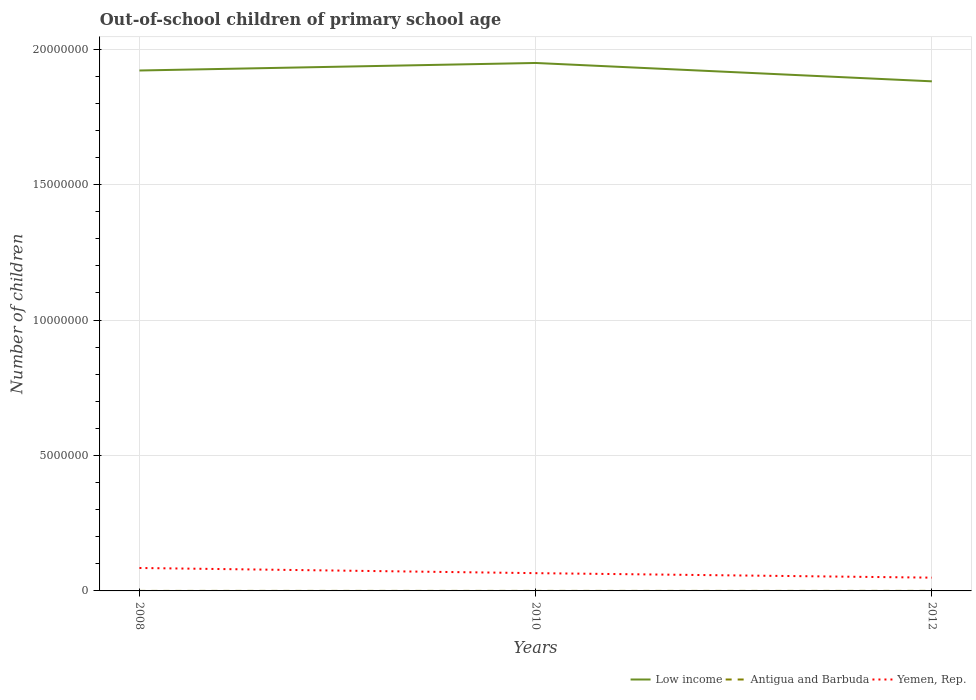How many different coloured lines are there?
Make the answer very short. 3. Does the line corresponding to Yemen, Rep. intersect with the line corresponding to Low income?
Your response must be concise. No. Is the number of lines equal to the number of legend labels?
Your answer should be compact. Yes. Across all years, what is the maximum number of out-of-school children in Yemen, Rep.?
Keep it short and to the point. 4.90e+05. In which year was the number of out-of-school children in Yemen, Rep. maximum?
Provide a short and direct response. 2012. What is the total number of out-of-school children in Yemen, Rep. in the graph?
Offer a very short reply. 1.66e+05. What is the difference between the highest and the second highest number of out-of-school children in Antigua and Barbuda?
Keep it short and to the point. 712. Is the number of out-of-school children in Yemen, Rep. strictly greater than the number of out-of-school children in Low income over the years?
Your answer should be compact. Yes. What is the difference between two consecutive major ticks on the Y-axis?
Keep it short and to the point. 5.00e+06. Does the graph contain any zero values?
Ensure brevity in your answer.  No. Does the graph contain grids?
Your answer should be compact. Yes. Where does the legend appear in the graph?
Offer a terse response. Bottom right. How are the legend labels stacked?
Provide a short and direct response. Horizontal. What is the title of the graph?
Your answer should be compact. Out-of-school children of primary school age. Does "Middle East & North Africa (developing only)" appear as one of the legend labels in the graph?
Provide a succinct answer. No. What is the label or title of the X-axis?
Your answer should be compact. Years. What is the label or title of the Y-axis?
Provide a succinct answer. Number of children. What is the Number of children of Low income in 2008?
Give a very brief answer. 1.92e+07. What is the Number of children in Antigua and Barbuda in 2008?
Offer a terse response. 786. What is the Number of children of Yemen, Rep. in 2008?
Offer a very short reply. 8.47e+05. What is the Number of children in Low income in 2010?
Keep it short and to the point. 1.95e+07. What is the Number of children of Antigua and Barbuda in 2010?
Give a very brief answer. 1146. What is the Number of children in Yemen, Rep. in 2010?
Provide a short and direct response. 6.56e+05. What is the Number of children of Low income in 2012?
Offer a very short reply. 1.88e+07. What is the Number of children in Antigua and Barbuda in 2012?
Provide a short and direct response. 1498. What is the Number of children of Yemen, Rep. in 2012?
Your answer should be compact. 4.90e+05. Across all years, what is the maximum Number of children of Low income?
Make the answer very short. 1.95e+07. Across all years, what is the maximum Number of children in Antigua and Barbuda?
Offer a very short reply. 1498. Across all years, what is the maximum Number of children in Yemen, Rep.?
Ensure brevity in your answer.  8.47e+05. Across all years, what is the minimum Number of children of Low income?
Your answer should be very brief. 1.88e+07. Across all years, what is the minimum Number of children in Antigua and Barbuda?
Provide a succinct answer. 786. Across all years, what is the minimum Number of children in Yemen, Rep.?
Offer a terse response. 4.90e+05. What is the total Number of children in Low income in the graph?
Make the answer very short. 5.75e+07. What is the total Number of children of Antigua and Barbuda in the graph?
Make the answer very short. 3430. What is the total Number of children of Yemen, Rep. in the graph?
Keep it short and to the point. 1.99e+06. What is the difference between the Number of children of Low income in 2008 and that in 2010?
Your answer should be compact. -2.78e+05. What is the difference between the Number of children of Antigua and Barbuda in 2008 and that in 2010?
Your answer should be compact. -360. What is the difference between the Number of children of Yemen, Rep. in 2008 and that in 2010?
Provide a short and direct response. 1.91e+05. What is the difference between the Number of children of Low income in 2008 and that in 2012?
Ensure brevity in your answer.  3.99e+05. What is the difference between the Number of children in Antigua and Barbuda in 2008 and that in 2012?
Make the answer very short. -712. What is the difference between the Number of children in Yemen, Rep. in 2008 and that in 2012?
Your answer should be very brief. 3.57e+05. What is the difference between the Number of children of Low income in 2010 and that in 2012?
Give a very brief answer. 6.77e+05. What is the difference between the Number of children in Antigua and Barbuda in 2010 and that in 2012?
Provide a succinct answer. -352. What is the difference between the Number of children in Yemen, Rep. in 2010 and that in 2012?
Make the answer very short. 1.66e+05. What is the difference between the Number of children of Low income in 2008 and the Number of children of Antigua and Barbuda in 2010?
Your answer should be compact. 1.92e+07. What is the difference between the Number of children in Low income in 2008 and the Number of children in Yemen, Rep. in 2010?
Offer a terse response. 1.86e+07. What is the difference between the Number of children of Antigua and Barbuda in 2008 and the Number of children of Yemen, Rep. in 2010?
Offer a very short reply. -6.55e+05. What is the difference between the Number of children of Low income in 2008 and the Number of children of Antigua and Barbuda in 2012?
Make the answer very short. 1.92e+07. What is the difference between the Number of children in Low income in 2008 and the Number of children in Yemen, Rep. in 2012?
Provide a succinct answer. 1.87e+07. What is the difference between the Number of children in Antigua and Barbuda in 2008 and the Number of children in Yemen, Rep. in 2012?
Your answer should be compact. -4.89e+05. What is the difference between the Number of children in Low income in 2010 and the Number of children in Antigua and Barbuda in 2012?
Offer a very short reply. 1.95e+07. What is the difference between the Number of children of Low income in 2010 and the Number of children of Yemen, Rep. in 2012?
Ensure brevity in your answer.  1.90e+07. What is the difference between the Number of children of Antigua and Barbuda in 2010 and the Number of children of Yemen, Rep. in 2012?
Make the answer very short. -4.89e+05. What is the average Number of children of Low income per year?
Your answer should be very brief. 1.92e+07. What is the average Number of children of Antigua and Barbuda per year?
Ensure brevity in your answer.  1143.33. What is the average Number of children in Yemen, Rep. per year?
Your answer should be compact. 6.64e+05. In the year 2008, what is the difference between the Number of children in Low income and Number of children in Antigua and Barbuda?
Provide a succinct answer. 1.92e+07. In the year 2008, what is the difference between the Number of children in Low income and Number of children in Yemen, Rep.?
Provide a short and direct response. 1.84e+07. In the year 2008, what is the difference between the Number of children in Antigua and Barbuda and Number of children in Yemen, Rep.?
Keep it short and to the point. -8.46e+05. In the year 2010, what is the difference between the Number of children of Low income and Number of children of Antigua and Barbuda?
Make the answer very short. 1.95e+07. In the year 2010, what is the difference between the Number of children of Low income and Number of children of Yemen, Rep.?
Your answer should be compact. 1.88e+07. In the year 2010, what is the difference between the Number of children of Antigua and Barbuda and Number of children of Yemen, Rep.?
Ensure brevity in your answer.  -6.55e+05. In the year 2012, what is the difference between the Number of children in Low income and Number of children in Antigua and Barbuda?
Ensure brevity in your answer.  1.88e+07. In the year 2012, what is the difference between the Number of children in Low income and Number of children in Yemen, Rep.?
Ensure brevity in your answer.  1.83e+07. In the year 2012, what is the difference between the Number of children of Antigua and Barbuda and Number of children of Yemen, Rep.?
Your answer should be compact. -4.89e+05. What is the ratio of the Number of children of Low income in 2008 to that in 2010?
Provide a short and direct response. 0.99. What is the ratio of the Number of children of Antigua and Barbuda in 2008 to that in 2010?
Give a very brief answer. 0.69. What is the ratio of the Number of children of Yemen, Rep. in 2008 to that in 2010?
Provide a succinct answer. 1.29. What is the ratio of the Number of children of Low income in 2008 to that in 2012?
Your answer should be very brief. 1.02. What is the ratio of the Number of children in Antigua and Barbuda in 2008 to that in 2012?
Offer a very short reply. 0.52. What is the ratio of the Number of children of Yemen, Rep. in 2008 to that in 2012?
Your answer should be very brief. 1.73. What is the ratio of the Number of children in Low income in 2010 to that in 2012?
Keep it short and to the point. 1.04. What is the ratio of the Number of children in Antigua and Barbuda in 2010 to that in 2012?
Provide a succinct answer. 0.77. What is the ratio of the Number of children in Yemen, Rep. in 2010 to that in 2012?
Keep it short and to the point. 1.34. What is the difference between the highest and the second highest Number of children of Low income?
Make the answer very short. 2.78e+05. What is the difference between the highest and the second highest Number of children of Antigua and Barbuda?
Your answer should be compact. 352. What is the difference between the highest and the second highest Number of children in Yemen, Rep.?
Offer a very short reply. 1.91e+05. What is the difference between the highest and the lowest Number of children in Low income?
Offer a terse response. 6.77e+05. What is the difference between the highest and the lowest Number of children in Antigua and Barbuda?
Your response must be concise. 712. What is the difference between the highest and the lowest Number of children in Yemen, Rep.?
Provide a short and direct response. 3.57e+05. 